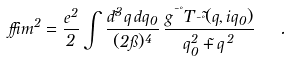Convert formula to latex. <formula><loc_0><loc_0><loc_500><loc_500>\delta m ^ { 2 } = { \frac { e ^ { 2 } } { 2 } } \int { \frac { d ^ { 3 } \vec { q } \, d q _ { 0 } } { ( 2 \pi ) ^ { 4 } } } \, { \frac { g ^ { \mu \nu } T _ { \mu \nu } ( \vec { q } , i q _ { 0 } ) } { q _ { 0 } ^ { 2 } + { \vec { q } } ^ { \, 2 } } } \ \ .</formula> 